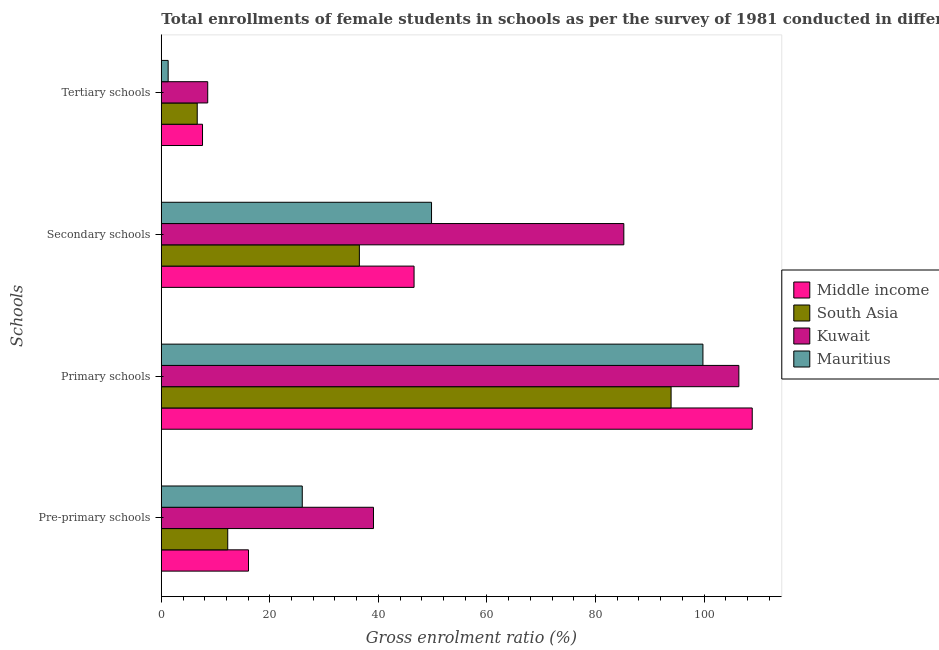How many different coloured bars are there?
Keep it short and to the point. 4. Are the number of bars per tick equal to the number of legend labels?
Give a very brief answer. Yes. How many bars are there on the 4th tick from the bottom?
Give a very brief answer. 4. What is the label of the 2nd group of bars from the top?
Provide a short and direct response. Secondary schools. What is the gross enrolment ratio(female) in pre-primary schools in Middle income?
Your answer should be compact. 16.06. Across all countries, what is the maximum gross enrolment ratio(female) in tertiary schools?
Your answer should be compact. 8.55. Across all countries, what is the minimum gross enrolment ratio(female) in tertiary schools?
Your answer should be compact. 1.26. In which country was the gross enrolment ratio(female) in pre-primary schools maximum?
Offer a very short reply. Kuwait. In which country was the gross enrolment ratio(female) in tertiary schools minimum?
Your answer should be very brief. Mauritius. What is the total gross enrolment ratio(female) in pre-primary schools in the graph?
Ensure brevity in your answer.  93.37. What is the difference between the gross enrolment ratio(female) in secondary schools in Middle income and that in Mauritius?
Offer a terse response. -3.22. What is the difference between the gross enrolment ratio(female) in pre-primary schools in Mauritius and the gross enrolment ratio(female) in secondary schools in Kuwait?
Offer a terse response. -59.25. What is the average gross enrolment ratio(female) in secondary schools per country?
Ensure brevity in your answer.  54.52. What is the difference between the gross enrolment ratio(female) in tertiary schools and gross enrolment ratio(female) in pre-primary schools in Middle income?
Keep it short and to the point. -8.47. In how many countries, is the gross enrolment ratio(female) in primary schools greater than 84 %?
Provide a succinct answer. 4. What is the ratio of the gross enrolment ratio(female) in primary schools in Kuwait to that in Middle income?
Your answer should be compact. 0.98. Is the gross enrolment ratio(female) in secondary schools in Kuwait less than that in South Asia?
Ensure brevity in your answer.  No. Is the difference between the gross enrolment ratio(female) in primary schools in Mauritius and South Asia greater than the difference between the gross enrolment ratio(female) in pre-primary schools in Mauritius and South Asia?
Ensure brevity in your answer.  No. What is the difference between the highest and the second highest gross enrolment ratio(female) in pre-primary schools?
Provide a short and direct response. 13.12. What is the difference between the highest and the lowest gross enrolment ratio(female) in tertiary schools?
Your answer should be very brief. 7.29. In how many countries, is the gross enrolment ratio(female) in pre-primary schools greater than the average gross enrolment ratio(female) in pre-primary schools taken over all countries?
Keep it short and to the point. 2. Is it the case that in every country, the sum of the gross enrolment ratio(female) in tertiary schools and gross enrolment ratio(female) in pre-primary schools is greater than the sum of gross enrolment ratio(female) in secondary schools and gross enrolment ratio(female) in primary schools?
Keep it short and to the point. No. What does the 1st bar from the top in Secondary schools represents?
Offer a very short reply. Mauritius. What does the 4th bar from the bottom in Tertiary schools represents?
Give a very brief answer. Mauritius. How many bars are there?
Provide a short and direct response. 16. How many countries are there in the graph?
Keep it short and to the point. 4. What is the difference between two consecutive major ticks on the X-axis?
Ensure brevity in your answer.  20. Are the values on the major ticks of X-axis written in scientific E-notation?
Ensure brevity in your answer.  No. Does the graph contain grids?
Provide a short and direct response. No. How are the legend labels stacked?
Your response must be concise. Vertical. What is the title of the graph?
Provide a succinct answer. Total enrollments of female students in schools as per the survey of 1981 conducted in different countries. Does "Mongolia" appear as one of the legend labels in the graph?
Your answer should be compact. No. What is the label or title of the X-axis?
Offer a very short reply. Gross enrolment ratio (%). What is the label or title of the Y-axis?
Ensure brevity in your answer.  Schools. What is the Gross enrolment ratio (%) of Middle income in Pre-primary schools?
Make the answer very short. 16.06. What is the Gross enrolment ratio (%) in South Asia in Pre-primary schools?
Offer a very short reply. 12.24. What is the Gross enrolment ratio (%) of Kuwait in Pre-primary schools?
Your answer should be very brief. 39.1. What is the Gross enrolment ratio (%) of Mauritius in Pre-primary schools?
Make the answer very short. 25.97. What is the Gross enrolment ratio (%) in Middle income in Primary schools?
Offer a terse response. 108.88. What is the Gross enrolment ratio (%) in South Asia in Primary schools?
Keep it short and to the point. 93.93. What is the Gross enrolment ratio (%) in Kuwait in Primary schools?
Make the answer very short. 106.42. What is the Gross enrolment ratio (%) in Mauritius in Primary schools?
Provide a short and direct response. 99.8. What is the Gross enrolment ratio (%) of Middle income in Secondary schools?
Your answer should be compact. 46.57. What is the Gross enrolment ratio (%) in South Asia in Secondary schools?
Ensure brevity in your answer.  36.49. What is the Gross enrolment ratio (%) in Kuwait in Secondary schools?
Give a very brief answer. 85.22. What is the Gross enrolment ratio (%) in Mauritius in Secondary schools?
Make the answer very short. 49.79. What is the Gross enrolment ratio (%) of Middle income in Tertiary schools?
Give a very brief answer. 7.59. What is the Gross enrolment ratio (%) of South Asia in Tertiary schools?
Offer a terse response. 6.62. What is the Gross enrolment ratio (%) in Kuwait in Tertiary schools?
Provide a succinct answer. 8.55. What is the Gross enrolment ratio (%) of Mauritius in Tertiary schools?
Your response must be concise. 1.26. Across all Schools, what is the maximum Gross enrolment ratio (%) in Middle income?
Offer a very short reply. 108.88. Across all Schools, what is the maximum Gross enrolment ratio (%) in South Asia?
Give a very brief answer. 93.93. Across all Schools, what is the maximum Gross enrolment ratio (%) of Kuwait?
Make the answer very short. 106.42. Across all Schools, what is the maximum Gross enrolment ratio (%) of Mauritius?
Your answer should be compact. 99.8. Across all Schools, what is the minimum Gross enrolment ratio (%) in Middle income?
Make the answer very short. 7.59. Across all Schools, what is the minimum Gross enrolment ratio (%) of South Asia?
Provide a succinct answer. 6.62. Across all Schools, what is the minimum Gross enrolment ratio (%) in Kuwait?
Offer a terse response. 8.55. Across all Schools, what is the minimum Gross enrolment ratio (%) of Mauritius?
Give a very brief answer. 1.26. What is the total Gross enrolment ratio (%) in Middle income in the graph?
Your answer should be compact. 179.11. What is the total Gross enrolment ratio (%) of South Asia in the graph?
Your answer should be very brief. 149.28. What is the total Gross enrolment ratio (%) in Kuwait in the graph?
Offer a terse response. 239.29. What is the total Gross enrolment ratio (%) in Mauritius in the graph?
Your answer should be compact. 176.82. What is the difference between the Gross enrolment ratio (%) in Middle income in Pre-primary schools and that in Primary schools?
Provide a succinct answer. -92.82. What is the difference between the Gross enrolment ratio (%) of South Asia in Pre-primary schools and that in Primary schools?
Ensure brevity in your answer.  -81.69. What is the difference between the Gross enrolment ratio (%) in Kuwait in Pre-primary schools and that in Primary schools?
Your answer should be compact. -67.32. What is the difference between the Gross enrolment ratio (%) in Mauritius in Pre-primary schools and that in Primary schools?
Ensure brevity in your answer.  -73.83. What is the difference between the Gross enrolment ratio (%) in Middle income in Pre-primary schools and that in Secondary schools?
Provide a short and direct response. -30.51. What is the difference between the Gross enrolment ratio (%) in South Asia in Pre-primary schools and that in Secondary schools?
Your answer should be compact. -24.26. What is the difference between the Gross enrolment ratio (%) of Kuwait in Pre-primary schools and that in Secondary schools?
Your answer should be compact. -46.13. What is the difference between the Gross enrolment ratio (%) of Mauritius in Pre-primary schools and that in Secondary schools?
Your answer should be very brief. -23.82. What is the difference between the Gross enrolment ratio (%) in Middle income in Pre-primary schools and that in Tertiary schools?
Make the answer very short. 8.47. What is the difference between the Gross enrolment ratio (%) in South Asia in Pre-primary schools and that in Tertiary schools?
Keep it short and to the point. 5.62. What is the difference between the Gross enrolment ratio (%) in Kuwait in Pre-primary schools and that in Tertiary schools?
Make the answer very short. 30.55. What is the difference between the Gross enrolment ratio (%) of Mauritius in Pre-primary schools and that in Tertiary schools?
Provide a short and direct response. 24.71. What is the difference between the Gross enrolment ratio (%) of Middle income in Primary schools and that in Secondary schools?
Give a very brief answer. 62.31. What is the difference between the Gross enrolment ratio (%) of South Asia in Primary schools and that in Secondary schools?
Your answer should be very brief. 57.44. What is the difference between the Gross enrolment ratio (%) of Kuwait in Primary schools and that in Secondary schools?
Your response must be concise. 21.19. What is the difference between the Gross enrolment ratio (%) of Mauritius in Primary schools and that in Secondary schools?
Make the answer very short. 50.01. What is the difference between the Gross enrolment ratio (%) in Middle income in Primary schools and that in Tertiary schools?
Keep it short and to the point. 101.29. What is the difference between the Gross enrolment ratio (%) in South Asia in Primary schools and that in Tertiary schools?
Provide a short and direct response. 87.31. What is the difference between the Gross enrolment ratio (%) of Kuwait in Primary schools and that in Tertiary schools?
Keep it short and to the point. 97.87. What is the difference between the Gross enrolment ratio (%) of Mauritius in Primary schools and that in Tertiary schools?
Make the answer very short. 98.54. What is the difference between the Gross enrolment ratio (%) in Middle income in Secondary schools and that in Tertiary schools?
Your answer should be very brief. 38.98. What is the difference between the Gross enrolment ratio (%) of South Asia in Secondary schools and that in Tertiary schools?
Keep it short and to the point. 29.88. What is the difference between the Gross enrolment ratio (%) in Kuwait in Secondary schools and that in Tertiary schools?
Keep it short and to the point. 76.67. What is the difference between the Gross enrolment ratio (%) in Mauritius in Secondary schools and that in Tertiary schools?
Ensure brevity in your answer.  48.53. What is the difference between the Gross enrolment ratio (%) in Middle income in Pre-primary schools and the Gross enrolment ratio (%) in South Asia in Primary schools?
Provide a short and direct response. -77.87. What is the difference between the Gross enrolment ratio (%) of Middle income in Pre-primary schools and the Gross enrolment ratio (%) of Kuwait in Primary schools?
Provide a succinct answer. -90.35. What is the difference between the Gross enrolment ratio (%) in Middle income in Pre-primary schools and the Gross enrolment ratio (%) in Mauritius in Primary schools?
Offer a terse response. -83.74. What is the difference between the Gross enrolment ratio (%) of South Asia in Pre-primary schools and the Gross enrolment ratio (%) of Kuwait in Primary schools?
Your response must be concise. -94.18. What is the difference between the Gross enrolment ratio (%) of South Asia in Pre-primary schools and the Gross enrolment ratio (%) of Mauritius in Primary schools?
Give a very brief answer. -87.56. What is the difference between the Gross enrolment ratio (%) of Kuwait in Pre-primary schools and the Gross enrolment ratio (%) of Mauritius in Primary schools?
Provide a short and direct response. -60.7. What is the difference between the Gross enrolment ratio (%) in Middle income in Pre-primary schools and the Gross enrolment ratio (%) in South Asia in Secondary schools?
Your response must be concise. -20.43. What is the difference between the Gross enrolment ratio (%) of Middle income in Pre-primary schools and the Gross enrolment ratio (%) of Kuwait in Secondary schools?
Offer a very short reply. -69.16. What is the difference between the Gross enrolment ratio (%) in Middle income in Pre-primary schools and the Gross enrolment ratio (%) in Mauritius in Secondary schools?
Make the answer very short. -33.73. What is the difference between the Gross enrolment ratio (%) of South Asia in Pre-primary schools and the Gross enrolment ratio (%) of Kuwait in Secondary schools?
Provide a short and direct response. -72.98. What is the difference between the Gross enrolment ratio (%) of South Asia in Pre-primary schools and the Gross enrolment ratio (%) of Mauritius in Secondary schools?
Your answer should be compact. -37.55. What is the difference between the Gross enrolment ratio (%) in Kuwait in Pre-primary schools and the Gross enrolment ratio (%) in Mauritius in Secondary schools?
Your answer should be very brief. -10.69. What is the difference between the Gross enrolment ratio (%) of Middle income in Pre-primary schools and the Gross enrolment ratio (%) of South Asia in Tertiary schools?
Provide a short and direct response. 9.44. What is the difference between the Gross enrolment ratio (%) in Middle income in Pre-primary schools and the Gross enrolment ratio (%) in Kuwait in Tertiary schools?
Make the answer very short. 7.51. What is the difference between the Gross enrolment ratio (%) of Middle income in Pre-primary schools and the Gross enrolment ratio (%) of Mauritius in Tertiary schools?
Ensure brevity in your answer.  14.8. What is the difference between the Gross enrolment ratio (%) of South Asia in Pre-primary schools and the Gross enrolment ratio (%) of Kuwait in Tertiary schools?
Ensure brevity in your answer.  3.69. What is the difference between the Gross enrolment ratio (%) in South Asia in Pre-primary schools and the Gross enrolment ratio (%) in Mauritius in Tertiary schools?
Your response must be concise. 10.98. What is the difference between the Gross enrolment ratio (%) in Kuwait in Pre-primary schools and the Gross enrolment ratio (%) in Mauritius in Tertiary schools?
Give a very brief answer. 37.83. What is the difference between the Gross enrolment ratio (%) in Middle income in Primary schools and the Gross enrolment ratio (%) in South Asia in Secondary schools?
Ensure brevity in your answer.  72.39. What is the difference between the Gross enrolment ratio (%) of Middle income in Primary schools and the Gross enrolment ratio (%) of Kuwait in Secondary schools?
Provide a short and direct response. 23.66. What is the difference between the Gross enrolment ratio (%) in Middle income in Primary schools and the Gross enrolment ratio (%) in Mauritius in Secondary schools?
Provide a succinct answer. 59.09. What is the difference between the Gross enrolment ratio (%) of South Asia in Primary schools and the Gross enrolment ratio (%) of Kuwait in Secondary schools?
Offer a very short reply. 8.71. What is the difference between the Gross enrolment ratio (%) in South Asia in Primary schools and the Gross enrolment ratio (%) in Mauritius in Secondary schools?
Your answer should be compact. 44.14. What is the difference between the Gross enrolment ratio (%) of Kuwait in Primary schools and the Gross enrolment ratio (%) of Mauritius in Secondary schools?
Keep it short and to the point. 56.63. What is the difference between the Gross enrolment ratio (%) in Middle income in Primary schools and the Gross enrolment ratio (%) in South Asia in Tertiary schools?
Your answer should be compact. 102.26. What is the difference between the Gross enrolment ratio (%) in Middle income in Primary schools and the Gross enrolment ratio (%) in Kuwait in Tertiary schools?
Ensure brevity in your answer.  100.33. What is the difference between the Gross enrolment ratio (%) in Middle income in Primary schools and the Gross enrolment ratio (%) in Mauritius in Tertiary schools?
Ensure brevity in your answer.  107.62. What is the difference between the Gross enrolment ratio (%) of South Asia in Primary schools and the Gross enrolment ratio (%) of Kuwait in Tertiary schools?
Your answer should be very brief. 85.38. What is the difference between the Gross enrolment ratio (%) of South Asia in Primary schools and the Gross enrolment ratio (%) of Mauritius in Tertiary schools?
Your answer should be very brief. 92.67. What is the difference between the Gross enrolment ratio (%) in Kuwait in Primary schools and the Gross enrolment ratio (%) in Mauritius in Tertiary schools?
Provide a succinct answer. 105.16. What is the difference between the Gross enrolment ratio (%) of Middle income in Secondary schools and the Gross enrolment ratio (%) of South Asia in Tertiary schools?
Keep it short and to the point. 39.95. What is the difference between the Gross enrolment ratio (%) of Middle income in Secondary schools and the Gross enrolment ratio (%) of Kuwait in Tertiary schools?
Offer a very short reply. 38.02. What is the difference between the Gross enrolment ratio (%) of Middle income in Secondary schools and the Gross enrolment ratio (%) of Mauritius in Tertiary schools?
Give a very brief answer. 45.31. What is the difference between the Gross enrolment ratio (%) in South Asia in Secondary schools and the Gross enrolment ratio (%) in Kuwait in Tertiary schools?
Provide a short and direct response. 27.94. What is the difference between the Gross enrolment ratio (%) in South Asia in Secondary schools and the Gross enrolment ratio (%) in Mauritius in Tertiary schools?
Offer a very short reply. 35.23. What is the difference between the Gross enrolment ratio (%) in Kuwait in Secondary schools and the Gross enrolment ratio (%) in Mauritius in Tertiary schools?
Your response must be concise. 83.96. What is the average Gross enrolment ratio (%) in Middle income per Schools?
Provide a succinct answer. 44.78. What is the average Gross enrolment ratio (%) of South Asia per Schools?
Ensure brevity in your answer.  37.32. What is the average Gross enrolment ratio (%) in Kuwait per Schools?
Provide a short and direct response. 59.82. What is the average Gross enrolment ratio (%) in Mauritius per Schools?
Your answer should be very brief. 44.21. What is the difference between the Gross enrolment ratio (%) in Middle income and Gross enrolment ratio (%) in South Asia in Pre-primary schools?
Offer a very short reply. 3.82. What is the difference between the Gross enrolment ratio (%) in Middle income and Gross enrolment ratio (%) in Kuwait in Pre-primary schools?
Provide a succinct answer. -23.03. What is the difference between the Gross enrolment ratio (%) in Middle income and Gross enrolment ratio (%) in Mauritius in Pre-primary schools?
Offer a terse response. -9.91. What is the difference between the Gross enrolment ratio (%) of South Asia and Gross enrolment ratio (%) of Kuwait in Pre-primary schools?
Provide a short and direct response. -26.86. What is the difference between the Gross enrolment ratio (%) in South Asia and Gross enrolment ratio (%) in Mauritius in Pre-primary schools?
Your answer should be very brief. -13.73. What is the difference between the Gross enrolment ratio (%) in Kuwait and Gross enrolment ratio (%) in Mauritius in Pre-primary schools?
Your answer should be very brief. 13.12. What is the difference between the Gross enrolment ratio (%) in Middle income and Gross enrolment ratio (%) in South Asia in Primary schools?
Your answer should be very brief. 14.95. What is the difference between the Gross enrolment ratio (%) of Middle income and Gross enrolment ratio (%) of Kuwait in Primary schools?
Give a very brief answer. 2.46. What is the difference between the Gross enrolment ratio (%) in Middle income and Gross enrolment ratio (%) in Mauritius in Primary schools?
Your response must be concise. 9.08. What is the difference between the Gross enrolment ratio (%) of South Asia and Gross enrolment ratio (%) of Kuwait in Primary schools?
Your response must be concise. -12.49. What is the difference between the Gross enrolment ratio (%) of South Asia and Gross enrolment ratio (%) of Mauritius in Primary schools?
Your answer should be compact. -5.87. What is the difference between the Gross enrolment ratio (%) in Kuwait and Gross enrolment ratio (%) in Mauritius in Primary schools?
Offer a very short reply. 6.62. What is the difference between the Gross enrolment ratio (%) of Middle income and Gross enrolment ratio (%) of South Asia in Secondary schools?
Offer a terse response. 10.08. What is the difference between the Gross enrolment ratio (%) in Middle income and Gross enrolment ratio (%) in Kuwait in Secondary schools?
Offer a terse response. -38.65. What is the difference between the Gross enrolment ratio (%) in Middle income and Gross enrolment ratio (%) in Mauritius in Secondary schools?
Your answer should be very brief. -3.22. What is the difference between the Gross enrolment ratio (%) of South Asia and Gross enrolment ratio (%) of Kuwait in Secondary schools?
Provide a short and direct response. -48.73. What is the difference between the Gross enrolment ratio (%) in South Asia and Gross enrolment ratio (%) in Mauritius in Secondary schools?
Your answer should be very brief. -13.29. What is the difference between the Gross enrolment ratio (%) of Kuwait and Gross enrolment ratio (%) of Mauritius in Secondary schools?
Keep it short and to the point. 35.43. What is the difference between the Gross enrolment ratio (%) in Middle income and Gross enrolment ratio (%) in South Asia in Tertiary schools?
Make the answer very short. 0.97. What is the difference between the Gross enrolment ratio (%) of Middle income and Gross enrolment ratio (%) of Kuwait in Tertiary schools?
Your answer should be compact. -0.96. What is the difference between the Gross enrolment ratio (%) in Middle income and Gross enrolment ratio (%) in Mauritius in Tertiary schools?
Offer a terse response. 6.33. What is the difference between the Gross enrolment ratio (%) in South Asia and Gross enrolment ratio (%) in Kuwait in Tertiary schools?
Your answer should be very brief. -1.93. What is the difference between the Gross enrolment ratio (%) of South Asia and Gross enrolment ratio (%) of Mauritius in Tertiary schools?
Make the answer very short. 5.36. What is the difference between the Gross enrolment ratio (%) in Kuwait and Gross enrolment ratio (%) in Mauritius in Tertiary schools?
Give a very brief answer. 7.29. What is the ratio of the Gross enrolment ratio (%) of Middle income in Pre-primary schools to that in Primary schools?
Ensure brevity in your answer.  0.15. What is the ratio of the Gross enrolment ratio (%) in South Asia in Pre-primary schools to that in Primary schools?
Give a very brief answer. 0.13. What is the ratio of the Gross enrolment ratio (%) of Kuwait in Pre-primary schools to that in Primary schools?
Provide a succinct answer. 0.37. What is the ratio of the Gross enrolment ratio (%) of Mauritius in Pre-primary schools to that in Primary schools?
Your response must be concise. 0.26. What is the ratio of the Gross enrolment ratio (%) of Middle income in Pre-primary schools to that in Secondary schools?
Your response must be concise. 0.34. What is the ratio of the Gross enrolment ratio (%) in South Asia in Pre-primary schools to that in Secondary schools?
Offer a very short reply. 0.34. What is the ratio of the Gross enrolment ratio (%) in Kuwait in Pre-primary schools to that in Secondary schools?
Keep it short and to the point. 0.46. What is the ratio of the Gross enrolment ratio (%) of Mauritius in Pre-primary schools to that in Secondary schools?
Your response must be concise. 0.52. What is the ratio of the Gross enrolment ratio (%) in Middle income in Pre-primary schools to that in Tertiary schools?
Your answer should be compact. 2.12. What is the ratio of the Gross enrolment ratio (%) in South Asia in Pre-primary schools to that in Tertiary schools?
Make the answer very short. 1.85. What is the ratio of the Gross enrolment ratio (%) in Kuwait in Pre-primary schools to that in Tertiary schools?
Provide a succinct answer. 4.57. What is the ratio of the Gross enrolment ratio (%) in Mauritius in Pre-primary schools to that in Tertiary schools?
Make the answer very short. 20.59. What is the ratio of the Gross enrolment ratio (%) of Middle income in Primary schools to that in Secondary schools?
Your answer should be very brief. 2.34. What is the ratio of the Gross enrolment ratio (%) of South Asia in Primary schools to that in Secondary schools?
Offer a very short reply. 2.57. What is the ratio of the Gross enrolment ratio (%) of Kuwait in Primary schools to that in Secondary schools?
Ensure brevity in your answer.  1.25. What is the ratio of the Gross enrolment ratio (%) in Mauritius in Primary schools to that in Secondary schools?
Make the answer very short. 2. What is the ratio of the Gross enrolment ratio (%) of Middle income in Primary schools to that in Tertiary schools?
Provide a succinct answer. 14.34. What is the ratio of the Gross enrolment ratio (%) in South Asia in Primary schools to that in Tertiary schools?
Provide a succinct answer. 14.19. What is the ratio of the Gross enrolment ratio (%) in Kuwait in Primary schools to that in Tertiary schools?
Keep it short and to the point. 12.45. What is the ratio of the Gross enrolment ratio (%) in Mauritius in Primary schools to that in Tertiary schools?
Make the answer very short. 79.14. What is the ratio of the Gross enrolment ratio (%) in Middle income in Secondary schools to that in Tertiary schools?
Your response must be concise. 6.13. What is the ratio of the Gross enrolment ratio (%) of South Asia in Secondary schools to that in Tertiary schools?
Make the answer very short. 5.51. What is the ratio of the Gross enrolment ratio (%) in Kuwait in Secondary schools to that in Tertiary schools?
Keep it short and to the point. 9.97. What is the ratio of the Gross enrolment ratio (%) in Mauritius in Secondary schools to that in Tertiary schools?
Your answer should be very brief. 39.48. What is the difference between the highest and the second highest Gross enrolment ratio (%) in Middle income?
Make the answer very short. 62.31. What is the difference between the highest and the second highest Gross enrolment ratio (%) in South Asia?
Provide a short and direct response. 57.44. What is the difference between the highest and the second highest Gross enrolment ratio (%) of Kuwait?
Offer a terse response. 21.19. What is the difference between the highest and the second highest Gross enrolment ratio (%) in Mauritius?
Your answer should be very brief. 50.01. What is the difference between the highest and the lowest Gross enrolment ratio (%) in Middle income?
Provide a short and direct response. 101.29. What is the difference between the highest and the lowest Gross enrolment ratio (%) of South Asia?
Make the answer very short. 87.31. What is the difference between the highest and the lowest Gross enrolment ratio (%) in Kuwait?
Offer a very short reply. 97.87. What is the difference between the highest and the lowest Gross enrolment ratio (%) in Mauritius?
Make the answer very short. 98.54. 